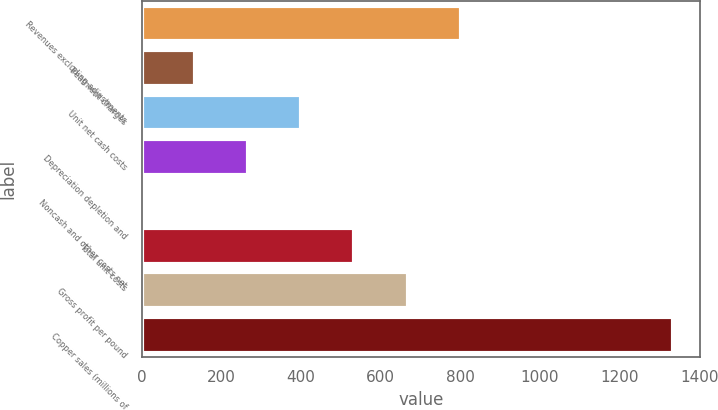Convert chart. <chart><loc_0><loc_0><loc_500><loc_500><bar_chart><fcel>Revenues excluding adjustments<fcel>Treatment charges<fcel>Unit net cash costs<fcel>Depreciation depletion and<fcel>Noncash and other costs net<fcel>Total unit costs<fcel>Gross profit per pound<fcel>Copper sales (millions of<nl><fcel>801.03<fcel>133.55<fcel>400.55<fcel>267.05<fcel>0.05<fcel>534.05<fcel>667.54<fcel>1335<nl></chart> 